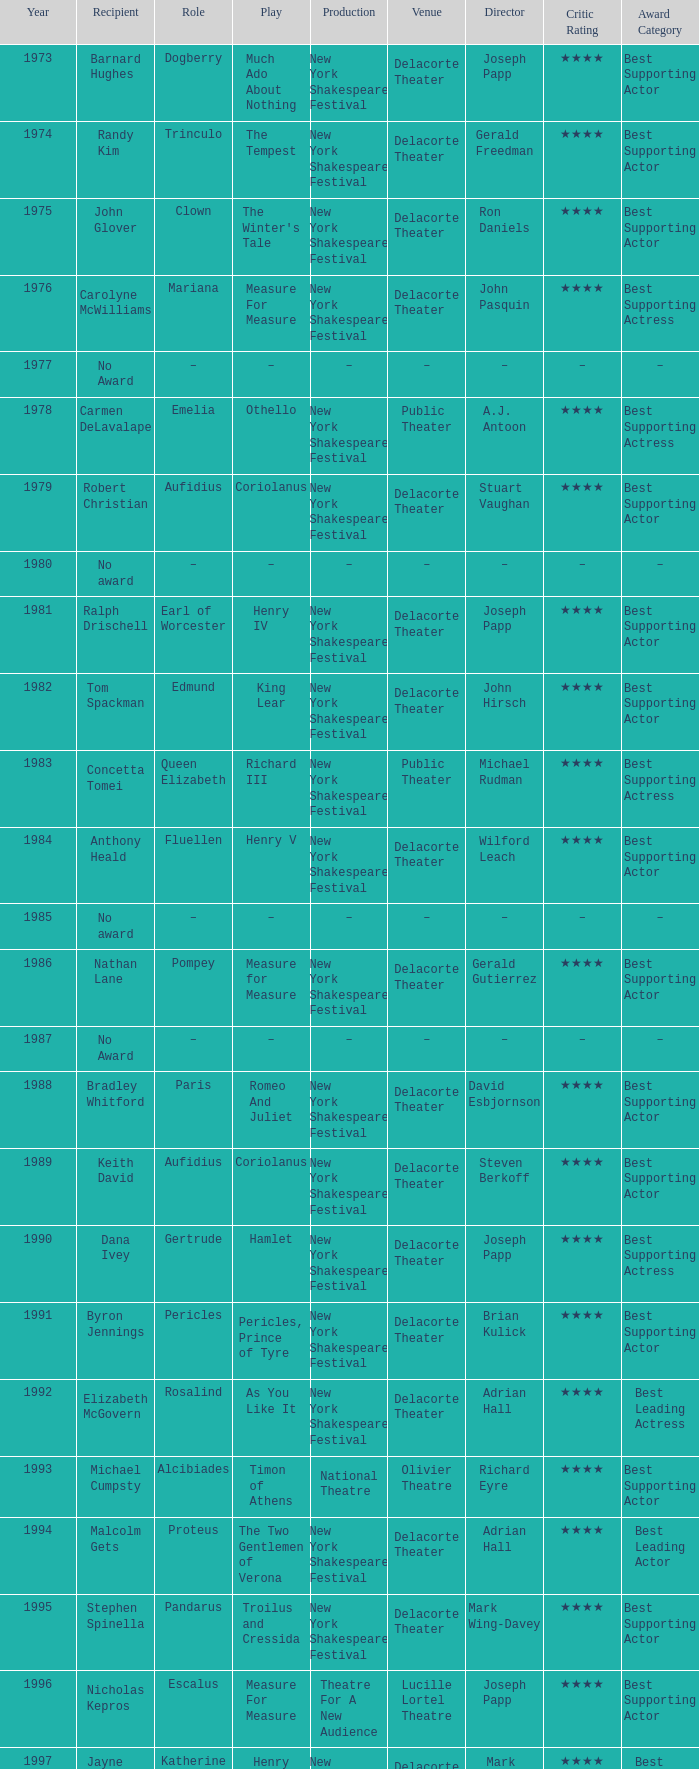In which average year does "much ado about nothing" take place, and who has received ray virta's contributions? 2002.0. 